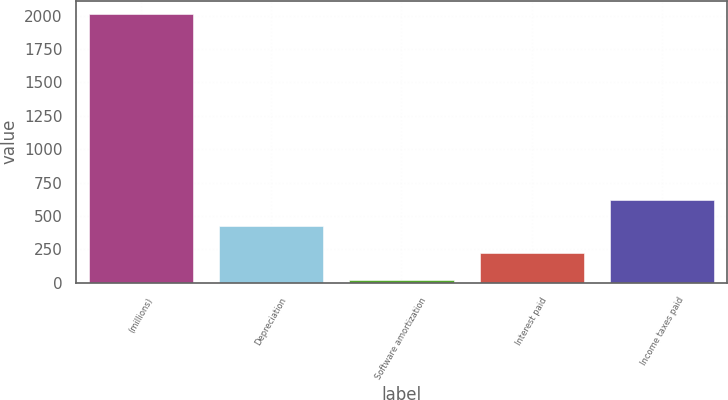Convert chart to OTSL. <chart><loc_0><loc_0><loc_500><loc_500><bar_chart><fcel>(millions)<fcel>Depreciation<fcel>Software amortization<fcel>Interest paid<fcel>Income taxes paid<nl><fcel>2012<fcel>421.36<fcel>23.7<fcel>222.53<fcel>620.19<nl></chart> 